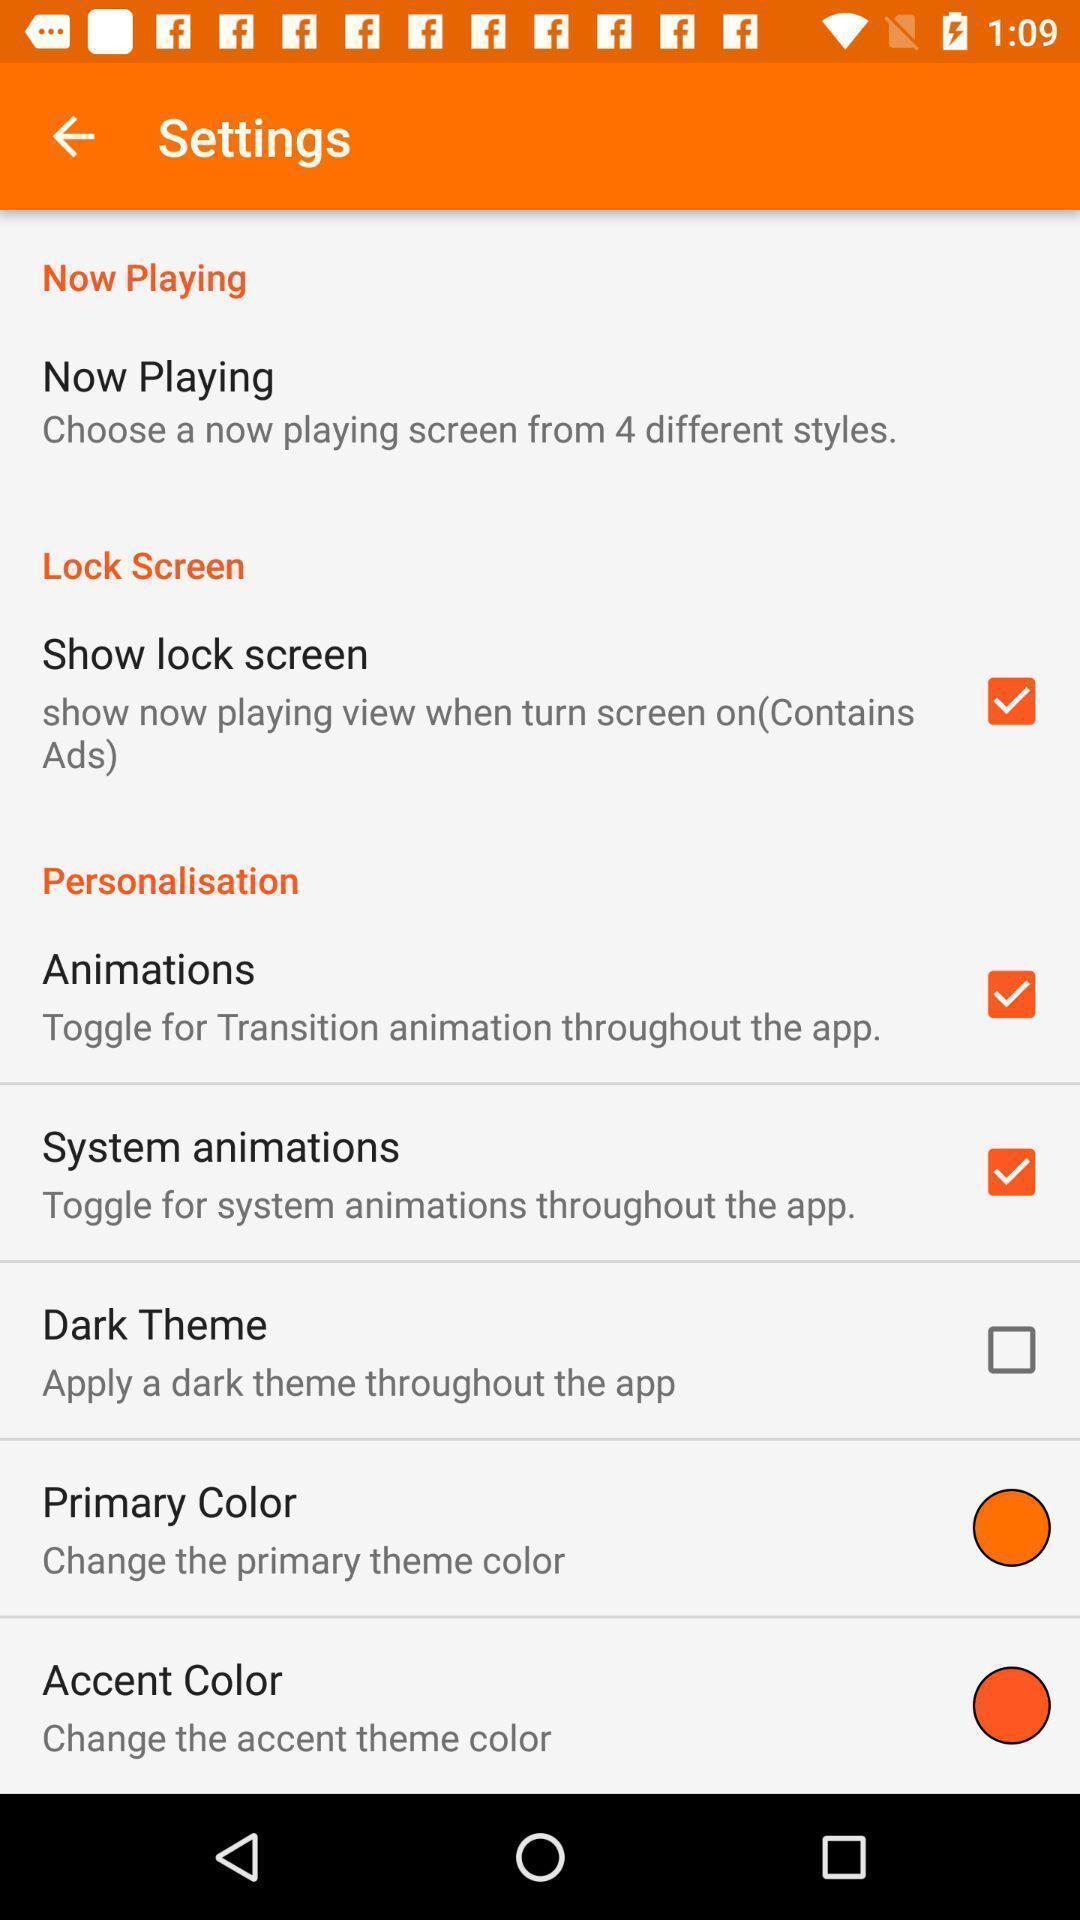Describe this image in words. Settings page of the app. 